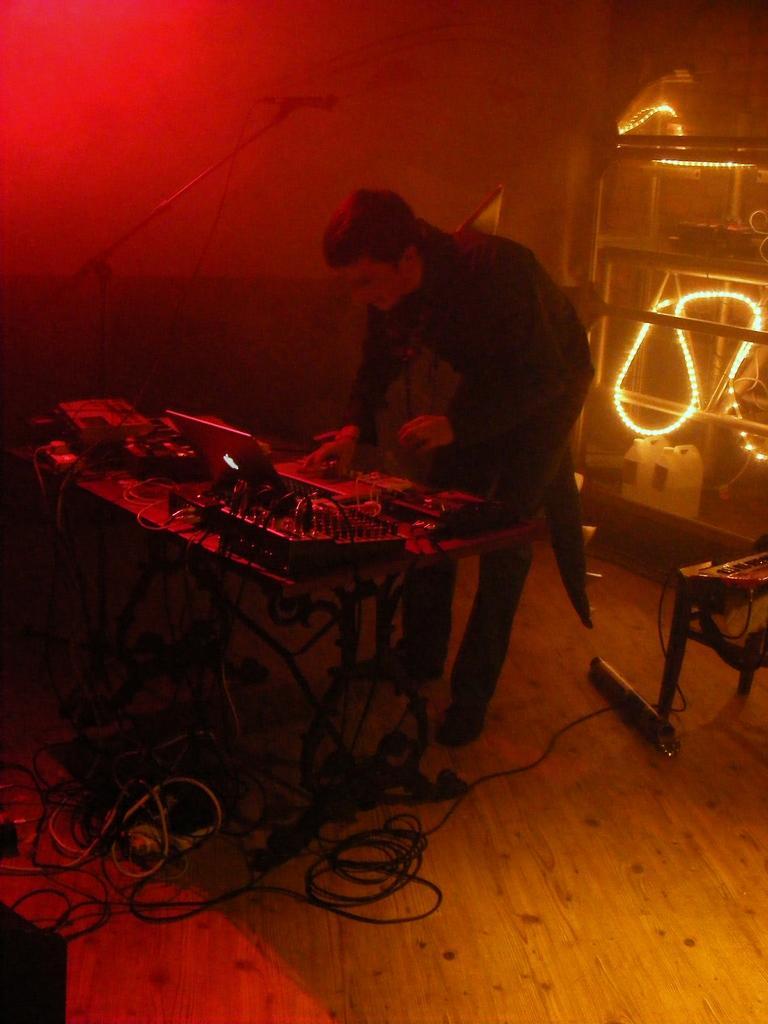How would you summarize this image in a sentence or two? I see this image is of red and yellow in color and I see person over here and I see a table on which there are lot of equipment and I see the wires. In the background I see the lights over here. 